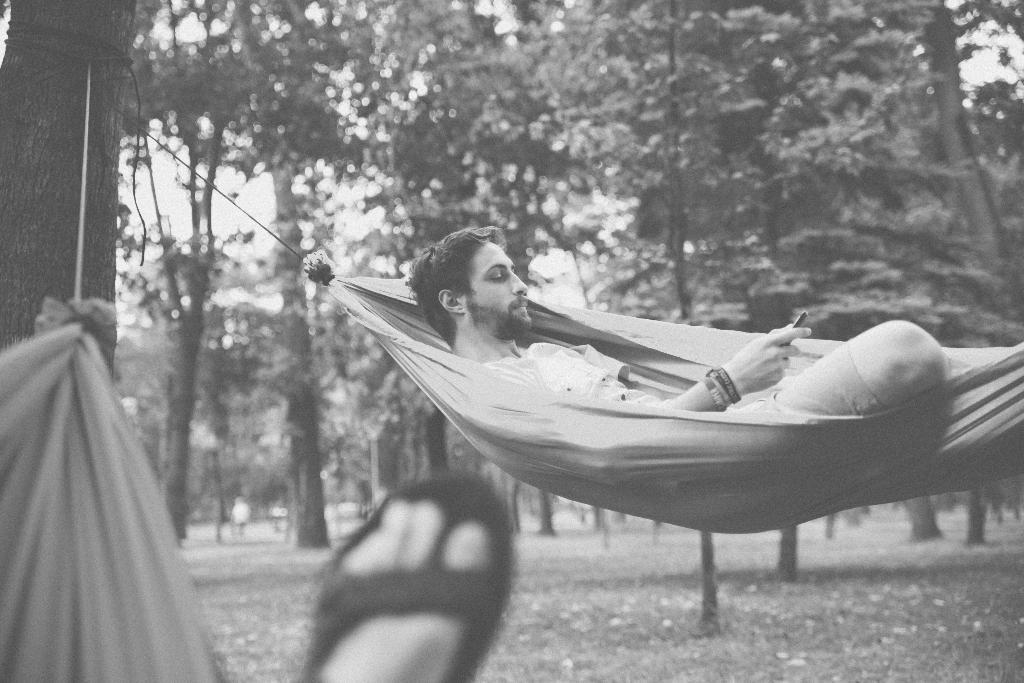Who is present in the image? There is a man in the image. What is the man wearing? The man is wearing clothes and bracelets. What is the man holding in his hand? The man is holding a gadget in his hand. What part of the man's body is visible in the image? Human legs are visible in the image. What type of natural environment can be seen in the image? There are trees in the image, and the sky is visible. What type of yam is being used as a volleyball in the image? There is no yam or volleyball present in the image. How many pins are visible on the man's shirt in the image? There are no pins visible on the man's shirt in the image. 